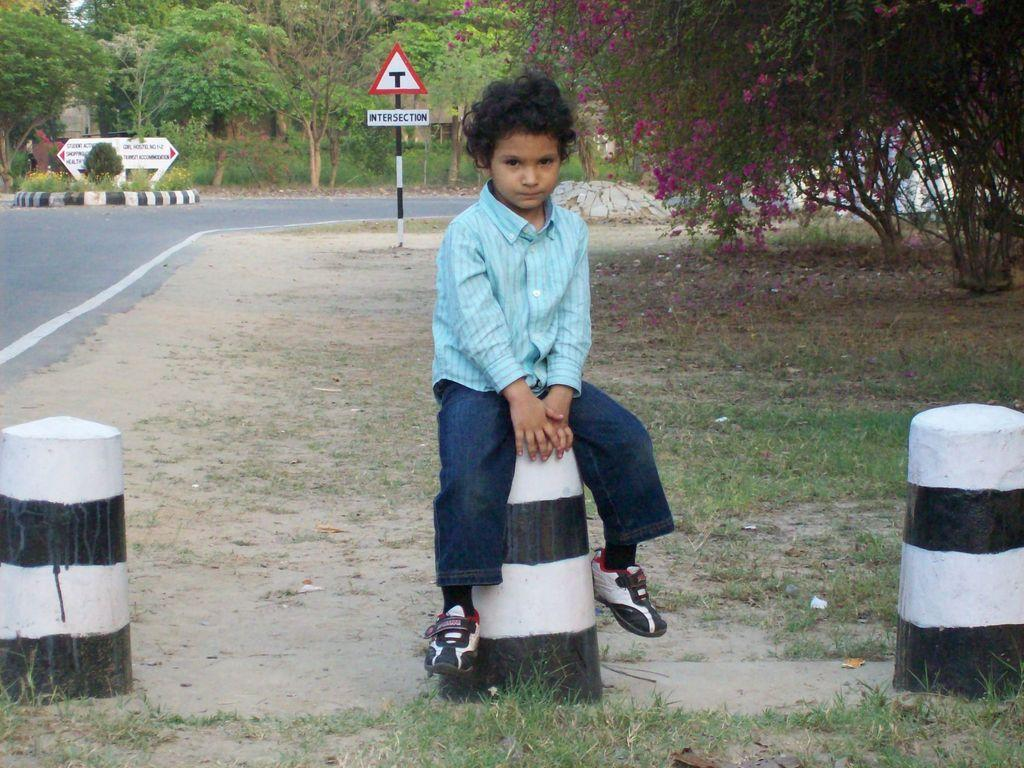Where was the image taken? The image was clicked outside. What can be seen in the background of the image? There are trees at the top of the image. What type of vegetation is visible in the middle of the image? There is grass in the middle of the image. Who is present in the image? There is a kid in the image. What is the kid wearing? The kid is wearing a blue dress. What type of business is being conducted in the image? There is no indication of any business activity in the image; it features a kid in a blue dress standing in a grassy area with trees in the background. Can you see any snakes in the image? There are no snakes present in the image. 